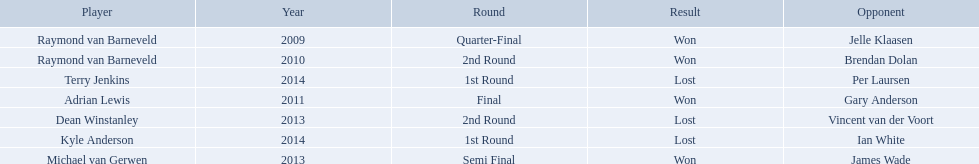Who are the players at the pdc world darts championship? Raymond van Barneveld, Raymond van Barneveld, Adrian Lewis, Dean Winstanley, Michael van Gerwen, Terry Jenkins, Kyle Anderson. When did kyle anderson lose? 2014. Which other players lost in 2014? Terry Jenkins. 